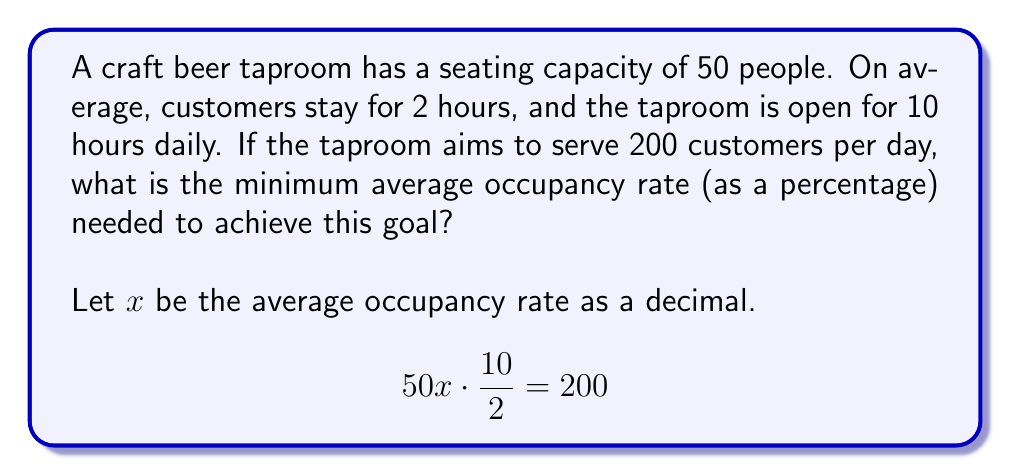Give your solution to this math problem. To solve this problem, we'll follow these steps:

1) First, let's understand what the equation represents:
   - $50x$ is the average number of occupied seats
   - $\frac{10}{2} = 5$ represents the number of customer turnovers per day (10 hours open / 2 hours per customer)
   - $200$ is the target number of customers per day

2) Now, let's solve the equation for $x$:

   $$50x \cdot 5 = 200$$
   
   $$250x = 200$$
   
   $$x = \frac{200}{250} = 0.8$$

3) Convert the decimal to a percentage:

   $$0.8 \cdot 100\% = 80\%$$

Therefore, the taproom needs to maintain an average occupancy rate of 80% to serve 200 customers per day.
Answer: 80% 